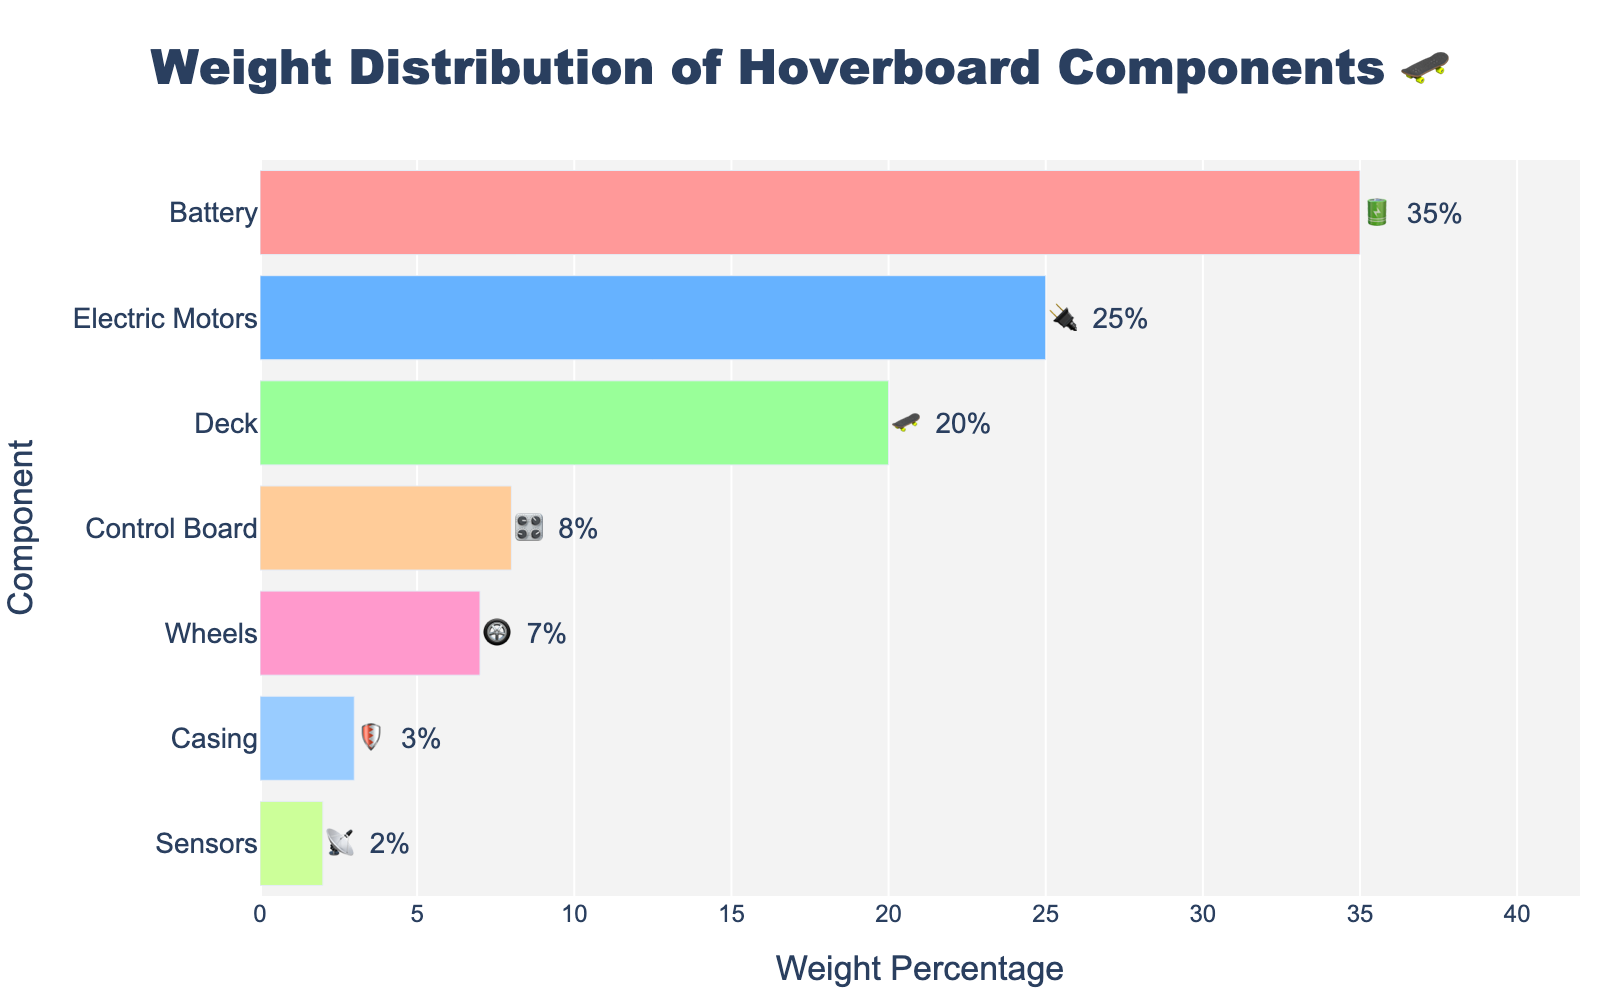What is the title of the chart? The title of the chart is typically displayed at the top of the figure. In this case, it reads 'Weight Distribution of Hoverboard Components 🛹'.
Answer: Weight Distribution of Hoverboard Components 🛹 Which component has the highest weight percentage? By examining the bar lengths, we see that the component with the longest bar corresponds to the Battery. The text label also shows 35%.
Answer: Battery What is the combined weight percentage of the Wheels and Casing? The weight percentages of the Wheels and Casing are 7% and 3%, respectively. Summing them up: 7 + 3 = 10.
Answer: 10% How much more weight percentage does the Battery have compared to the Control Board? The Battery's weight percentage is 35% and the Control Board's is 8%. The difference is 35 - 8 = 27.
Answer: 27% Which component has the least weight percentage? The component with the least weight percentage is identified by the shortest bar. Here, it is the Sensors with 2%.
Answer: Sensors How much weight percentage does the Deck contribute relative to the total weight percentage of the Control Board and Sensors? The Deck contributes 20%, while the Control Board and Sensors contribute 8% and 2%, respectively. Adding Control Board and Sensors: 8 + 2 = 10. So, the Deck is 20 relative to 10, or 20/10 = 2 times greater.
Answer: 2 times By how many percentage points does the weight of the Electric Motors exceed that of the Wheels? The Electric Motors have a weight percentage of 25%, and the Wheels have 7%. The difference is 25 - 7 = 18 percentage points.
Answer: 18 percentage points What is the sum of the weight percentages of the three lightest components? The three lightest components are Casing (3%), Sensors (2%), and Wheels (7%). Summing them: 3 + 2 + 7 = 12.
Answer: 12% How many components have a weight percentage greater than 20%? Checking the bar lengths and labels, the components with more than 20% are Battery (35%) and Electric Motors (25%). Thus, there are 2 components.
Answer: 2 